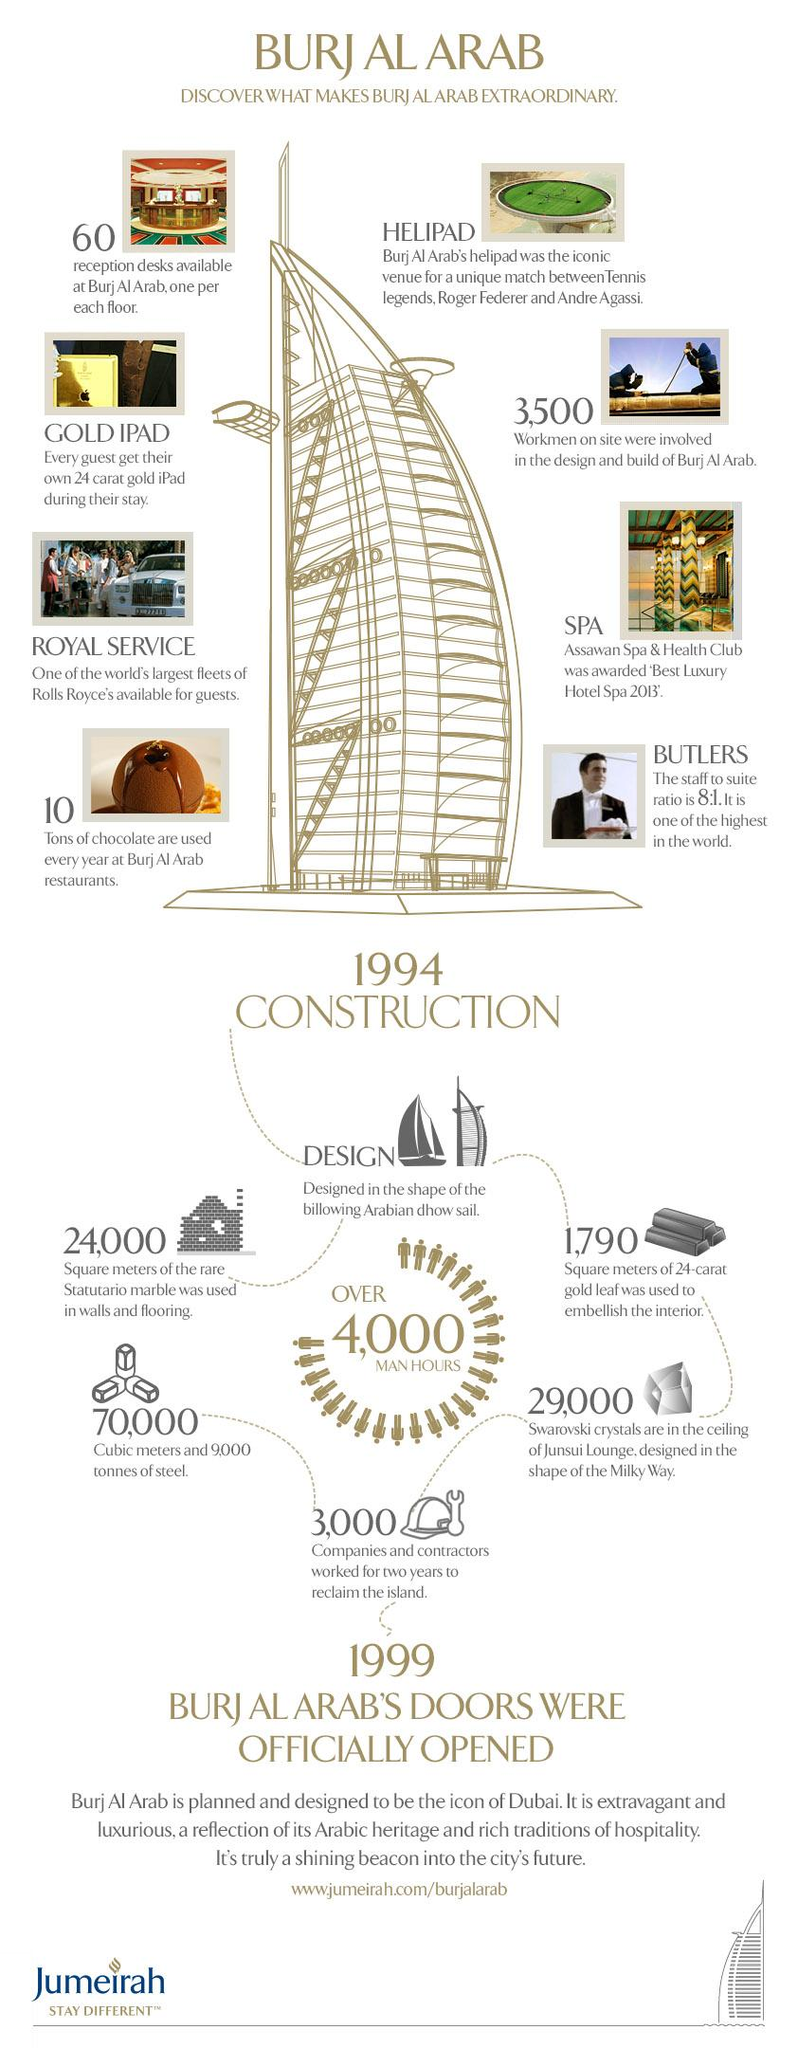Mention a couple of crucial points in this snapshot. The embellishment of the interior of Burj Al Arab with 24-carat gold leaf required the use of 1,790 square meters of the precious material. It is estimated that annually, approximately 10 tons of chocolate are used at the restaurants at Burj Al Arab. The ceiling of the Junsui Lounge was designed in the shape of the milky way and featured 29,000 Swarovski crystals, which added a dazzling touch to the overall design of the space. The construction of the Burj Al Arab began in 1994. There are 60 reception desks available at Burj Al Arab. 